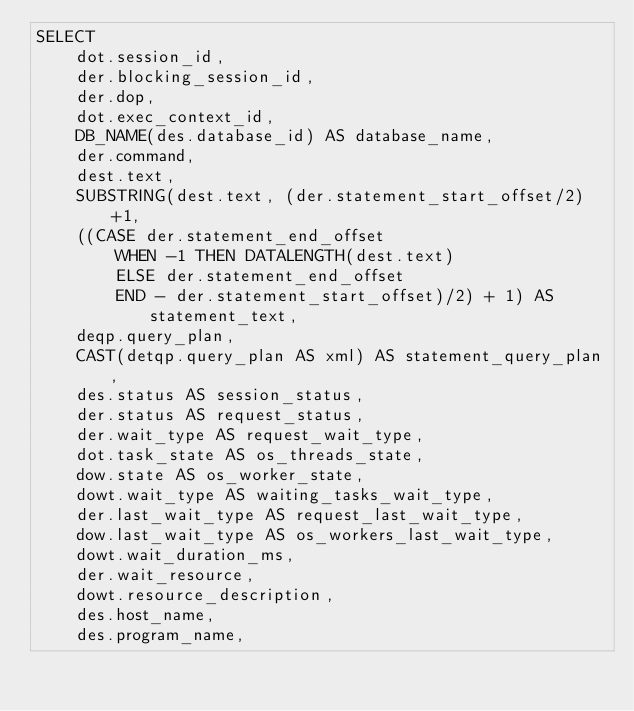Convert code to text. <code><loc_0><loc_0><loc_500><loc_500><_SQL_>SELECT 
	dot.session_id,
	der.blocking_session_id,
	der.dop,
	dot.exec_context_id,
	DB_NAME(des.database_id) AS database_name,
	der.command,
	dest.text,
	SUBSTRING(dest.text, (der.statement_start_offset/2)+1,   
    ((CASE der.statement_end_offset  
        WHEN -1 THEN DATALENGTH(dest.text)  
        ELSE der.statement_end_offset  
        END - der.statement_start_offset)/2) + 1) AS statement_text,
	deqp.query_plan,
	CAST(detqp.query_plan AS xml) AS statement_query_plan,
	des.status AS session_status,
	der.status AS request_status,
	der.wait_type AS request_wait_type,
	dot.task_state AS os_threads_state,
	dow.state AS os_worker_state,
	dowt.wait_type AS waiting_tasks_wait_type,
	der.last_wait_type AS request_last_wait_type,
	dow.last_wait_type AS os_workers_last_wait_type,
	dowt.wait_duration_ms,
	der.wait_resource,
	dowt.resource_description,
	des.host_name,
	des.program_name,</code> 